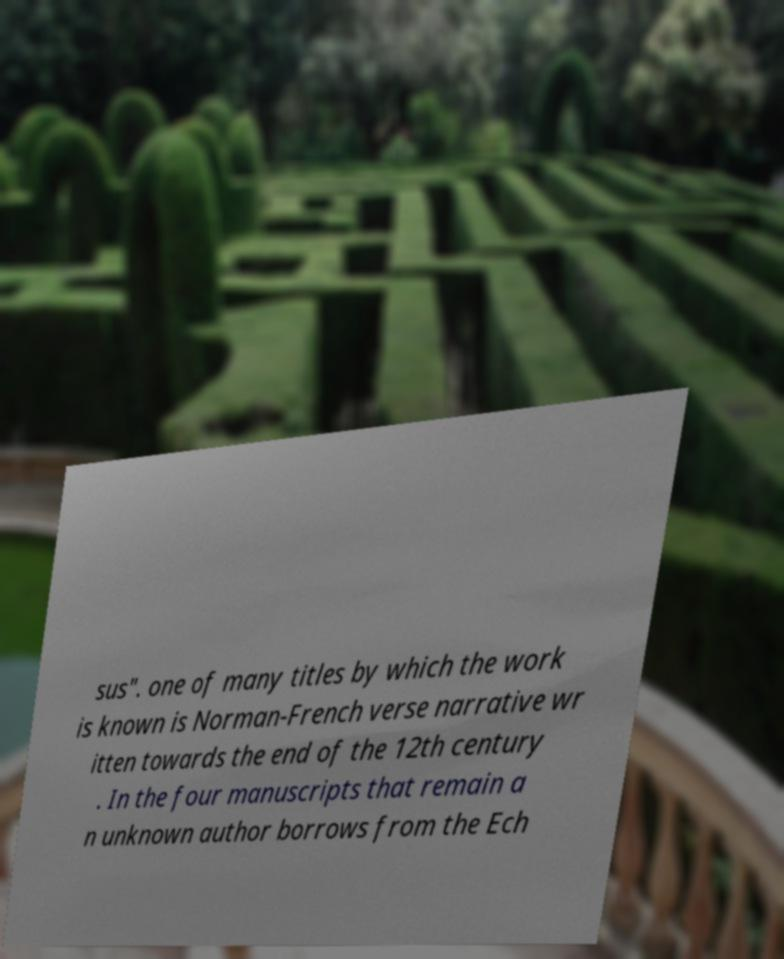Could you assist in decoding the text presented in this image and type it out clearly? sus". one of many titles by which the work is known is Norman-French verse narrative wr itten towards the end of the 12th century . In the four manuscripts that remain a n unknown author borrows from the Ech 